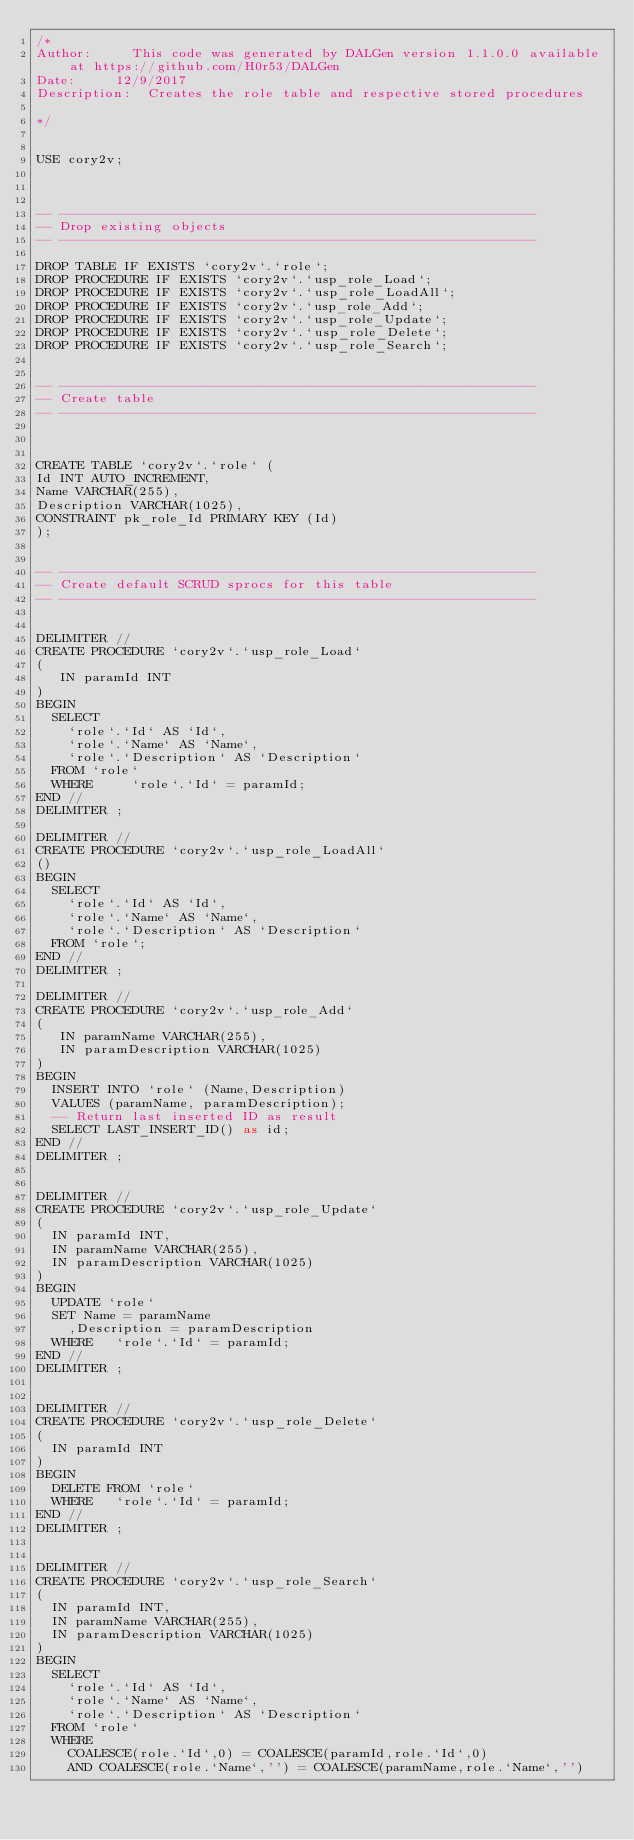<code> <loc_0><loc_0><loc_500><loc_500><_SQL_>/*
Author:			This code was generated by DALGen version 1.1.0.0 available at https://github.com/H0r53/DALGen
Date:			12/9/2017
Description:	Creates the role table and respective stored procedures

*/


USE cory2v;



-- ------------------------------------------------------------
-- Drop existing objects
-- ------------------------------------------------------------

DROP TABLE IF EXISTS `cory2v`.`role`;
DROP PROCEDURE IF EXISTS `cory2v`.`usp_role_Load`;
DROP PROCEDURE IF EXISTS `cory2v`.`usp_role_LoadAll`;
DROP PROCEDURE IF EXISTS `cory2v`.`usp_role_Add`;
DROP PROCEDURE IF EXISTS `cory2v`.`usp_role_Update`;
DROP PROCEDURE IF EXISTS `cory2v`.`usp_role_Delete`;
DROP PROCEDURE IF EXISTS `cory2v`.`usp_role_Search`;


-- ------------------------------------------------------------
-- Create table
-- ------------------------------------------------------------



CREATE TABLE `cory2v`.`role` (
Id INT AUTO_INCREMENT,
Name VARCHAR(255),
Description VARCHAR(1025),
CONSTRAINT pk_role_Id PRIMARY KEY (Id)
);


-- ------------------------------------------------------------
-- Create default SCRUD sprocs for this table
-- ------------------------------------------------------------


DELIMITER //
CREATE PROCEDURE `cory2v`.`usp_role_Load`
(
	 IN paramId INT
)
BEGIN
	SELECT
		`role`.`Id` AS `Id`,
		`role`.`Name` AS `Name`,
		`role`.`Description` AS `Description`
	FROM `role`
	WHERE 		`role`.`Id` = paramId;
END //
DELIMITER ;

DELIMITER //
CREATE PROCEDURE `cory2v`.`usp_role_LoadAll`
()
BEGIN
	SELECT
		`role`.`Id` AS `Id`,
		`role`.`Name` AS `Name`,
		`role`.`Description` AS `Description`
	FROM `role`;
END //
DELIMITER ;

DELIMITER //
CREATE PROCEDURE `cory2v`.`usp_role_Add`
(
	 IN paramName VARCHAR(255),
	 IN paramDescription VARCHAR(1025)
)
BEGIN
	INSERT INTO `role` (Name,Description)
	VALUES (paramName, paramDescription);
	-- Return last inserted ID as result
	SELECT LAST_INSERT_ID() as id;
END //
DELIMITER ;


DELIMITER //
CREATE PROCEDURE `cory2v`.`usp_role_Update`
(
	IN paramId INT,
	IN paramName VARCHAR(255),
	IN paramDescription VARCHAR(1025)
)
BEGIN
	UPDATE `role`
	SET Name = paramName
		,Description = paramDescription
	WHERE		`role`.`Id` = paramId;
END //
DELIMITER ;


DELIMITER //
CREATE PROCEDURE `cory2v`.`usp_role_Delete`
(
	IN paramId INT
)
BEGIN
	DELETE FROM `role`
	WHERE		`role`.`Id` = paramId;
END //
DELIMITER ;


DELIMITER //
CREATE PROCEDURE `cory2v`.`usp_role_Search`
(
	IN paramId INT,
	IN paramName VARCHAR(255),
	IN paramDescription VARCHAR(1025)
)
BEGIN
	SELECT
		`role`.`Id` AS `Id`,
		`role`.`Name` AS `Name`,
		`role`.`Description` AS `Description`
	FROM `role`
	WHERE
		COALESCE(role.`Id`,0) = COALESCE(paramId,role.`Id`,0)
		AND COALESCE(role.`Name`,'') = COALESCE(paramName,role.`Name`,'')</code> 